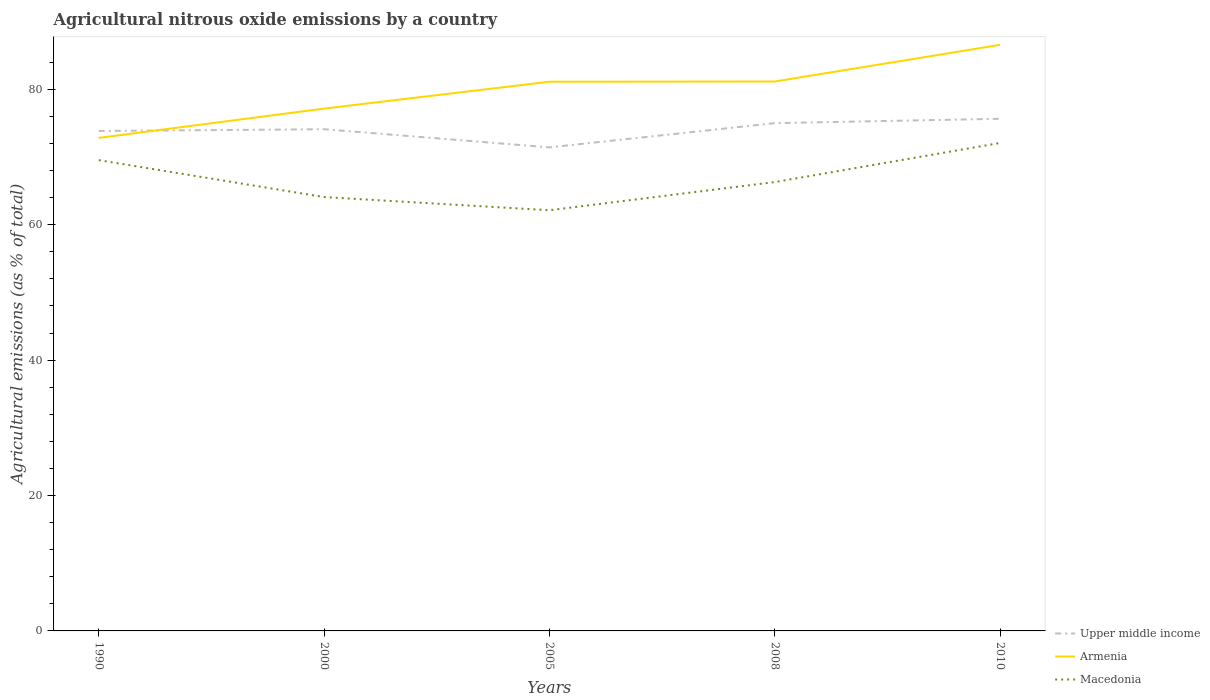Is the number of lines equal to the number of legend labels?
Ensure brevity in your answer.  Yes. Across all years, what is the maximum amount of agricultural nitrous oxide emitted in Macedonia?
Your answer should be compact. 62.13. In which year was the amount of agricultural nitrous oxide emitted in Armenia maximum?
Offer a terse response. 1990. What is the total amount of agricultural nitrous oxide emitted in Macedonia in the graph?
Offer a terse response. -7.99. What is the difference between the highest and the second highest amount of agricultural nitrous oxide emitted in Macedonia?
Ensure brevity in your answer.  9.94. How many lines are there?
Make the answer very short. 3. How many years are there in the graph?
Ensure brevity in your answer.  5. Does the graph contain any zero values?
Make the answer very short. No. Does the graph contain grids?
Provide a succinct answer. No. Where does the legend appear in the graph?
Your answer should be compact. Bottom right. How many legend labels are there?
Keep it short and to the point. 3. How are the legend labels stacked?
Give a very brief answer. Vertical. What is the title of the graph?
Your answer should be compact. Agricultural nitrous oxide emissions by a country. What is the label or title of the Y-axis?
Provide a succinct answer. Agricultural emissions (as % of total). What is the Agricultural emissions (as % of total) of Upper middle income in 1990?
Your response must be concise. 73.84. What is the Agricultural emissions (as % of total) of Armenia in 1990?
Make the answer very short. 72.82. What is the Agricultural emissions (as % of total) in Macedonia in 1990?
Your answer should be compact. 69.53. What is the Agricultural emissions (as % of total) in Upper middle income in 2000?
Provide a short and direct response. 74.1. What is the Agricultural emissions (as % of total) in Armenia in 2000?
Give a very brief answer. 77.14. What is the Agricultural emissions (as % of total) of Macedonia in 2000?
Provide a succinct answer. 64.08. What is the Agricultural emissions (as % of total) in Upper middle income in 2005?
Your answer should be very brief. 71.42. What is the Agricultural emissions (as % of total) of Armenia in 2005?
Your answer should be compact. 81.11. What is the Agricultural emissions (as % of total) of Macedonia in 2005?
Your response must be concise. 62.13. What is the Agricultural emissions (as % of total) of Upper middle income in 2008?
Provide a succinct answer. 75. What is the Agricultural emissions (as % of total) of Armenia in 2008?
Offer a very short reply. 81.15. What is the Agricultural emissions (as % of total) of Macedonia in 2008?
Ensure brevity in your answer.  66.29. What is the Agricultural emissions (as % of total) of Upper middle income in 2010?
Give a very brief answer. 75.64. What is the Agricultural emissions (as % of total) in Armenia in 2010?
Offer a terse response. 86.56. What is the Agricultural emissions (as % of total) of Macedonia in 2010?
Ensure brevity in your answer.  72.07. Across all years, what is the maximum Agricultural emissions (as % of total) in Upper middle income?
Your answer should be very brief. 75.64. Across all years, what is the maximum Agricultural emissions (as % of total) of Armenia?
Offer a terse response. 86.56. Across all years, what is the maximum Agricultural emissions (as % of total) in Macedonia?
Offer a terse response. 72.07. Across all years, what is the minimum Agricultural emissions (as % of total) in Upper middle income?
Your answer should be very brief. 71.42. Across all years, what is the minimum Agricultural emissions (as % of total) of Armenia?
Provide a short and direct response. 72.82. Across all years, what is the minimum Agricultural emissions (as % of total) in Macedonia?
Your answer should be compact. 62.13. What is the total Agricultural emissions (as % of total) in Upper middle income in the graph?
Provide a succinct answer. 370. What is the total Agricultural emissions (as % of total) in Armenia in the graph?
Your answer should be very brief. 398.78. What is the total Agricultural emissions (as % of total) of Macedonia in the graph?
Provide a succinct answer. 334.11. What is the difference between the Agricultural emissions (as % of total) of Upper middle income in 1990 and that in 2000?
Give a very brief answer. -0.26. What is the difference between the Agricultural emissions (as % of total) in Armenia in 1990 and that in 2000?
Your response must be concise. -4.32. What is the difference between the Agricultural emissions (as % of total) of Macedonia in 1990 and that in 2000?
Provide a succinct answer. 5.45. What is the difference between the Agricultural emissions (as % of total) of Upper middle income in 1990 and that in 2005?
Provide a short and direct response. 2.42. What is the difference between the Agricultural emissions (as % of total) of Armenia in 1990 and that in 2005?
Provide a succinct answer. -8.29. What is the difference between the Agricultural emissions (as % of total) of Macedonia in 1990 and that in 2005?
Provide a short and direct response. 7.4. What is the difference between the Agricultural emissions (as % of total) of Upper middle income in 1990 and that in 2008?
Your answer should be compact. -1.16. What is the difference between the Agricultural emissions (as % of total) of Armenia in 1990 and that in 2008?
Give a very brief answer. -8.33. What is the difference between the Agricultural emissions (as % of total) in Macedonia in 1990 and that in 2008?
Provide a short and direct response. 3.24. What is the difference between the Agricultural emissions (as % of total) of Upper middle income in 1990 and that in 2010?
Your answer should be compact. -1.8. What is the difference between the Agricultural emissions (as % of total) of Armenia in 1990 and that in 2010?
Your answer should be very brief. -13.74. What is the difference between the Agricultural emissions (as % of total) in Macedonia in 1990 and that in 2010?
Ensure brevity in your answer.  -2.54. What is the difference between the Agricultural emissions (as % of total) of Upper middle income in 2000 and that in 2005?
Provide a succinct answer. 2.68. What is the difference between the Agricultural emissions (as % of total) of Armenia in 2000 and that in 2005?
Provide a short and direct response. -3.97. What is the difference between the Agricultural emissions (as % of total) in Macedonia in 2000 and that in 2005?
Provide a short and direct response. 1.95. What is the difference between the Agricultural emissions (as % of total) of Upper middle income in 2000 and that in 2008?
Provide a short and direct response. -0.9. What is the difference between the Agricultural emissions (as % of total) in Armenia in 2000 and that in 2008?
Provide a short and direct response. -4. What is the difference between the Agricultural emissions (as % of total) of Macedonia in 2000 and that in 2008?
Offer a very short reply. -2.22. What is the difference between the Agricultural emissions (as % of total) of Upper middle income in 2000 and that in 2010?
Offer a very short reply. -1.54. What is the difference between the Agricultural emissions (as % of total) in Armenia in 2000 and that in 2010?
Your response must be concise. -9.42. What is the difference between the Agricultural emissions (as % of total) in Macedonia in 2000 and that in 2010?
Your response must be concise. -7.99. What is the difference between the Agricultural emissions (as % of total) in Upper middle income in 2005 and that in 2008?
Your answer should be compact. -3.58. What is the difference between the Agricultural emissions (as % of total) in Armenia in 2005 and that in 2008?
Offer a terse response. -0.03. What is the difference between the Agricultural emissions (as % of total) in Macedonia in 2005 and that in 2008?
Give a very brief answer. -4.16. What is the difference between the Agricultural emissions (as % of total) of Upper middle income in 2005 and that in 2010?
Provide a short and direct response. -4.23. What is the difference between the Agricultural emissions (as % of total) in Armenia in 2005 and that in 2010?
Keep it short and to the point. -5.45. What is the difference between the Agricultural emissions (as % of total) of Macedonia in 2005 and that in 2010?
Give a very brief answer. -9.94. What is the difference between the Agricultural emissions (as % of total) of Upper middle income in 2008 and that in 2010?
Keep it short and to the point. -0.65. What is the difference between the Agricultural emissions (as % of total) of Armenia in 2008 and that in 2010?
Your answer should be very brief. -5.41. What is the difference between the Agricultural emissions (as % of total) of Macedonia in 2008 and that in 2010?
Make the answer very short. -5.78. What is the difference between the Agricultural emissions (as % of total) in Upper middle income in 1990 and the Agricultural emissions (as % of total) in Armenia in 2000?
Give a very brief answer. -3.31. What is the difference between the Agricultural emissions (as % of total) in Upper middle income in 1990 and the Agricultural emissions (as % of total) in Macedonia in 2000?
Provide a succinct answer. 9.76. What is the difference between the Agricultural emissions (as % of total) in Armenia in 1990 and the Agricultural emissions (as % of total) in Macedonia in 2000?
Make the answer very short. 8.74. What is the difference between the Agricultural emissions (as % of total) in Upper middle income in 1990 and the Agricultural emissions (as % of total) in Armenia in 2005?
Your answer should be very brief. -7.27. What is the difference between the Agricultural emissions (as % of total) of Upper middle income in 1990 and the Agricultural emissions (as % of total) of Macedonia in 2005?
Your response must be concise. 11.71. What is the difference between the Agricultural emissions (as % of total) of Armenia in 1990 and the Agricultural emissions (as % of total) of Macedonia in 2005?
Make the answer very short. 10.69. What is the difference between the Agricultural emissions (as % of total) of Upper middle income in 1990 and the Agricultural emissions (as % of total) of Armenia in 2008?
Offer a terse response. -7.31. What is the difference between the Agricultural emissions (as % of total) of Upper middle income in 1990 and the Agricultural emissions (as % of total) of Macedonia in 2008?
Provide a succinct answer. 7.55. What is the difference between the Agricultural emissions (as % of total) in Armenia in 1990 and the Agricultural emissions (as % of total) in Macedonia in 2008?
Give a very brief answer. 6.53. What is the difference between the Agricultural emissions (as % of total) of Upper middle income in 1990 and the Agricultural emissions (as % of total) of Armenia in 2010?
Offer a terse response. -12.72. What is the difference between the Agricultural emissions (as % of total) of Upper middle income in 1990 and the Agricultural emissions (as % of total) of Macedonia in 2010?
Give a very brief answer. 1.77. What is the difference between the Agricultural emissions (as % of total) of Armenia in 1990 and the Agricultural emissions (as % of total) of Macedonia in 2010?
Your response must be concise. 0.75. What is the difference between the Agricultural emissions (as % of total) in Upper middle income in 2000 and the Agricultural emissions (as % of total) in Armenia in 2005?
Your answer should be very brief. -7.01. What is the difference between the Agricultural emissions (as % of total) of Upper middle income in 2000 and the Agricultural emissions (as % of total) of Macedonia in 2005?
Your answer should be very brief. 11.97. What is the difference between the Agricultural emissions (as % of total) of Armenia in 2000 and the Agricultural emissions (as % of total) of Macedonia in 2005?
Ensure brevity in your answer.  15.01. What is the difference between the Agricultural emissions (as % of total) in Upper middle income in 2000 and the Agricultural emissions (as % of total) in Armenia in 2008?
Offer a very short reply. -7.05. What is the difference between the Agricultural emissions (as % of total) of Upper middle income in 2000 and the Agricultural emissions (as % of total) of Macedonia in 2008?
Give a very brief answer. 7.8. What is the difference between the Agricultural emissions (as % of total) of Armenia in 2000 and the Agricultural emissions (as % of total) of Macedonia in 2008?
Give a very brief answer. 10.85. What is the difference between the Agricultural emissions (as % of total) in Upper middle income in 2000 and the Agricultural emissions (as % of total) in Armenia in 2010?
Your answer should be very brief. -12.46. What is the difference between the Agricultural emissions (as % of total) in Upper middle income in 2000 and the Agricultural emissions (as % of total) in Macedonia in 2010?
Your answer should be compact. 2.03. What is the difference between the Agricultural emissions (as % of total) in Armenia in 2000 and the Agricultural emissions (as % of total) in Macedonia in 2010?
Give a very brief answer. 5.07. What is the difference between the Agricultural emissions (as % of total) of Upper middle income in 2005 and the Agricultural emissions (as % of total) of Armenia in 2008?
Make the answer very short. -9.73. What is the difference between the Agricultural emissions (as % of total) in Upper middle income in 2005 and the Agricultural emissions (as % of total) in Macedonia in 2008?
Provide a short and direct response. 5.12. What is the difference between the Agricultural emissions (as % of total) in Armenia in 2005 and the Agricultural emissions (as % of total) in Macedonia in 2008?
Offer a terse response. 14.82. What is the difference between the Agricultural emissions (as % of total) in Upper middle income in 2005 and the Agricultural emissions (as % of total) in Armenia in 2010?
Your response must be concise. -15.14. What is the difference between the Agricultural emissions (as % of total) in Upper middle income in 2005 and the Agricultural emissions (as % of total) in Macedonia in 2010?
Ensure brevity in your answer.  -0.65. What is the difference between the Agricultural emissions (as % of total) of Armenia in 2005 and the Agricultural emissions (as % of total) of Macedonia in 2010?
Provide a succinct answer. 9.04. What is the difference between the Agricultural emissions (as % of total) in Upper middle income in 2008 and the Agricultural emissions (as % of total) in Armenia in 2010?
Your response must be concise. -11.56. What is the difference between the Agricultural emissions (as % of total) in Upper middle income in 2008 and the Agricultural emissions (as % of total) in Macedonia in 2010?
Your response must be concise. 2.93. What is the difference between the Agricultural emissions (as % of total) of Armenia in 2008 and the Agricultural emissions (as % of total) of Macedonia in 2010?
Your answer should be very brief. 9.07. What is the average Agricultural emissions (as % of total) of Upper middle income per year?
Provide a succinct answer. 74. What is the average Agricultural emissions (as % of total) of Armenia per year?
Provide a short and direct response. 79.76. What is the average Agricultural emissions (as % of total) in Macedonia per year?
Provide a short and direct response. 66.82. In the year 1990, what is the difference between the Agricultural emissions (as % of total) in Upper middle income and Agricultural emissions (as % of total) in Armenia?
Your response must be concise. 1.02. In the year 1990, what is the difference between the Agricultural emissions (as % of total) of Upper middle income and Agricultural emissions (as % of total) of Macedonia?
Your answer should be very brief. 4.31. In the year 1990, what is the difference between the Agricultural emissions (as % of total) in Armenia and Agricultural emissions (as % of total) in Macedonia?
Offer a very short reply. 3.29. In the year 2000, what is the difference between the Agricultural emissions (as % of total) of Upper middle income and Agricultural emissions (as % of total) of Armenia?
Ensure brevity in your answer.  -3.05. In the year 2000, what is the difference between the Agricultural emissions (as % of total) of Upper middle income and Agricultural emissions (as % of total) of Macedonia?
Your response must be concise. 10.02. In the year 2000, what is the difference between the Agricultural emissions (as % of total) of Armenia and Agricultural emissions (as % of total) of Macedonia?
Your answer should be compact. 13.07. In the year 2005, what is the difference between the Agricultural emissions (as % of total) of Upper middle income and Agricultural emissions (as % of total) of Armenia?
Offer a very short reply. -9.7. In the year 2005, what is the difference between the Agricultural emissions (as % of total) of Upper middle income and Agricultural emissions (as % of total) of Macedonia?
Your response must be concise. 9.28. In the year 2005, what is the difference between the Agricultural emissions (as % of total) of Armenia and Agricultural emissions (as % of total) of Macedonia?
Offer a very short reply. 18.98. In the year 2008, what is the difference between the Agricultural emissions (as % of total) of Upper middle income and Agricultural emissions (as % of total) of Armenia?
Ensure brevity in your answer.  -6.15. In the year 2008, what is the difference between the Agricultural emissions (as % of total) in Upper middle income and Agricultural emissions (as % of total) in Macedonia?
Provide a short and direct response. 8.7. In the year 2008, what is the difference between the Agricultural emissions (as % of total) in Armenia and Agricultural emissions (as % of total) in Macedonia?
Your answer should be very brief. 14.85. In the year 2010, what is the difference between the Agricultural emissions (as % of total) of Upper middle income and Agricultural emissions (as % of total) of Armenia?
Your answer should be compact. -10.92. In the year 2010, what is the difference between the Agricultural emissions (as % of total) in Upper middle income and Agricultural emissions (as % of total) in Macedonia?
Your answer should be very brief. 3.57. In the year 2010, what is the difference between the Agricultural emissions (as % of total) of Armenia and Agricultural emissions (as % of total) of Macedonia?
Provide a succinct answer. 14.49. What is the ratio of the Agricultural emissions (as % of total) of Upper middle income in 1990 to that in 2000?
Offer a terse response. 1. What is the ratio of the Agricultural emissions (as % of total) of Armenia in 1990 to that in 2000?
Provide a short and direct response. 0.94. What is the ratio of the Agricultural emissions (as % of total) of Macedonia in 1990 to that in 2000?
Provide a short and direct response. 1.09. What is the ratio of the Agricultural emissions (as % of total) in Upper middle income in 1990 to that in 2005?
Provide a short and direct response. 1.03. What is the ratio of the Agricultural emissions (as % of total) of Armenia in 1990 to that in 2005?
Provide a succinct answer. 0.9. What is the ratio of the Agricultural emissions (as % of total) of Macedonia in 1990 to that in 2005?
Keep it short and to the point. 1.12. What is the ratio of the Agricultural emissions (as % of total) in Upper middle income in 1990 to that in 2008?
Offer a terse response. 0.98. What is the ratio of the Agricultural emissions (as % of total) in Armenia in 1990 to that in 2008?
Your answer should be compact. 0.9. What is the ratio of the Agricultural emissions (as % of total) of Macedonia in 1990 to that in 2008?
Your answer should be compact. 1.05. What is the ratio of the Agricultural emissions (as % of total) in Upper middle income in 1990 to that in 2010?
Provide a succinct answer. 0.98. What is the ratio of the Agricultural emissions (as % of total) in Armenia in 1990 to that in 2010?
Ensure brevity in your answer.  0.84. What is the ratio of the Agricultural emissions (as % of total) in Macedonia in 1990 to that in 2010?
Provide a short and direct response. 0.96. What is the ratio of the Agricultural emissions (as % of total) of Upper middle income in 2000 to that in 2005?
Your answer should be very brief. 1.04. What is the ratio of the Agricultural emissions (as % of total) of Armenia in 2000 to that in 2005?
Keep it short and to the point. 0.95. What is the ratio of the Agricultural emissions (as % of total) in Macedonia in 2000 to that in 2005?
Make the answer very short. 1.03. What is the ratio of the Agricultural emissions (as % of total) of Upper middle income in 2000 to that in 2008?
Make the answer very short. 0.99. What is the ratio of the Agricultural emissions (as % of total) of Armenia in 2000 to that in 2008?
Ensure brevity in your answer.  0.95. What is the ratio of the Agricultural emissions (as % of total) in Macedonia in 2000 to that in 2008?
Your answer should be very brief. 0.97. What is the ratio of the Agricultural emissions (as % of total) in Upper middle income in 2000 to that in 2010?
Offer a terse response. 0.98. What is the ratio of the Agricultural emissions (as % of total) in Armenia in 2000 to that in 2010?
Your answer should be compact. 0.89. What is the ratio of the Agricultural emissions (as % of total) of Macedonia in 2000 to that in 2010?
Offer a very short reply. 0.89. What is the ratio of the Agricultural emissions (as % of total) of Upper middle income in 2005 to that in 2008?
Give a very brief answer. 0.95. What is the ratio of the Agricultural emissions (as % of total) in Armenia in 2005 to that in 2008?
Your answer should be compact. 1. What is the ratio of the Agricultural emissions (as % of total) in Macedonia in 2005 to that in 2008?
Give a very brief answer. 0.94. What is the ratio of the Agricultural emissions (as % of total) in Upper middle income in 2005 to that in 2010?
Keep it short and to the point. 0.94. What is the ratio of the Agricultural emissions (as % of total) in Armenia in 2005 to that in 2010?
Provide a succinct answer. 0.94. What is the ratio of the Agricultural emissions (as % of total) of Macedonia in 2005 to that in 2010?
Offer a very short reply. 0.86. What is the ratio of the Agricultural emissions (as % of total) of Upper middle income in 2008 to that in 2010?
Your answer should be very brief. 0.99. What is the ratio of the Agricultural emissions (as % of total) of Armenia in 2008 to that in 2010?
Your answer should be compact. 0.94. What is the ratio of the Agricultural emissions (as % of total) in Macedonia in 2008 to that in 2010?
Your response must be concise. 0.92. What is the difference between the highest and the second highest Agricultural emissions (as % of total) of Upper middle income?
Offer a very short reply. 0.65. What is the difference between the highest and the second highest Agricultural emissions (as % of total) in Armenia?
Provide a succinct answer. 5.41. What is the difference between the highest and the second highest Agricultural emissions (as % of total) of Macedonia?
Provide a succinct answer. 2.54. What is the difference between the highest and the lowest Agricultural emissions (as % of total) of Upper middle income?
Keep it short and to the point. 4.23. What is the difference between the highest and the lowest Agricultural emissions (as % of total) of Armenia?
Make the answer very short. 13.74. What is the difference between the highest and the lowest Agricultural emissions (as % of total) in Macedonia?
Your answer should be very brief. 9.94. 